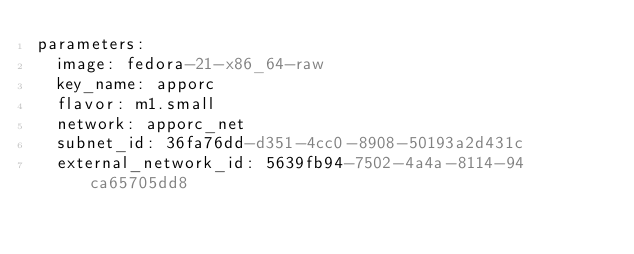Convert code to text. <code><loc_0><loc_0><loc_500><loc_500><_YAML_>parameters:
  image: fedora-21-x86_64-raw
  key_name: apporc
  flavor: m1.small
  network: apporc_net
  subnet_id: 36fa76dd-d351-4cc0-8908-50193a2d431c
  external_network_id: 5639fb94-7502-4a4a-8114-94ca65705dd8
</code> 